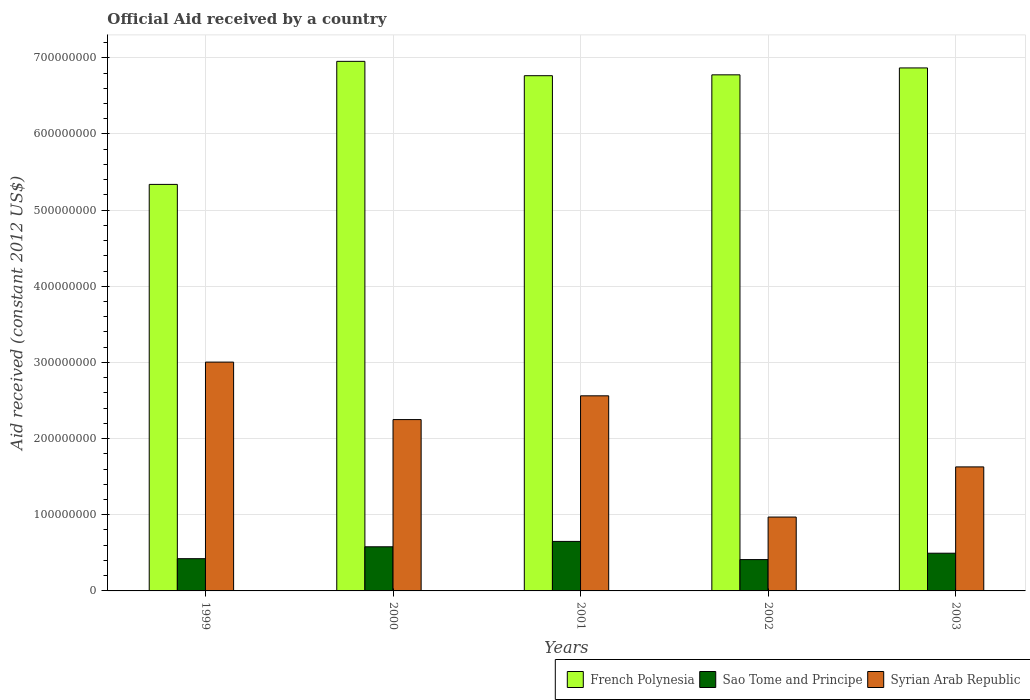Are the number of bars on each tick of the X-axis equal?
Your response must be concise. Yes. How many bars are there on the 2nd tick from the right?
Give a very brief answer. 3. What is the label of the 2nd group of bars from the left?
Your answer should be compact. 2000. In how many cases, is the number of bars for a given year not equal to the number of legend labels?
Your response must be concise. 0. What is the net official aid received in Syrian Arab Republic in 2000?
Your answer should be compact. 2.25e+08. Across all years, what is the maximum net official aid received in Sao Tome and Principe?
Keep it short and to the point. 6.50e+07. Across all years, what is the minimum net official aid received in Syrian Arab Republic?
Offer a very short reply. 9.70e+07. In which year was the net official aid received in French Polynesia minimum?
Make the answer very short. 1999. What is the total net official aid received in Sao Tome and Principe in the graph?
Offer a very short reply. 2.56e+08. What is the difference between the net official aid received in French Polynesia in 2001 and that in 2002?
Give a very brief answer. -1.13e+06. What is the difference between the net official aid received in French Polynesia in 2002 and the net official aid received in Sao Tome and Principe in 1999?
Your response must be concise. 6.35e+08. What is the average net official aid received in Sao Tome and Principe per year?
Provide a succinct answer. 5.12e+07. In the year 2001, what is the difference between the net official aid received in Sao Tome and Principe and net official aid received in French Polynesia?
Your answer should be very brief. -6.11e+08. In how many years, is the net official aid received in Sao Tome and Principe greater than 120000000 US$?
Offer a very short reply. 0. What is the ratio of the net official aid received in Sao Tome and Principe in 2002 to that in 2003?
Offer a terse response. 0.83. What is the difference between the highest and the second highest net official aid received in French Polynesia?
Provide a short and direct response. 8.64e+06. What is the difference between the highest and the lowest net official aid received in Sao Tome and Principe?
Offer a terse response. 2.39e+07. In how many years, is the net official aid received in French Polynesia greater than the average net official aid received in French Polynesia taken over all years?
Provide a succinct answer. 4. Is the sum of the net official aid received in Sao Tome and Principe in 2002 and 2003 greater than the maximum net official aid received in French Polynesia across all years?
Give a very brief answer. No. What does the 2nd bar from the left in 2001 represents?
Offer a terse response. Sao Tome and Principe. What does the 1st bar from the right in 2002 represents?
Ensure brevity in your answer.  Syrian Arab Republic. Is it the case that in every year, the sum of the net official aid received in French Polynesia and net official aid received in Syrian Arab Republic is greater than the net official aid received in Sao Tome and Principe?
Keep it short and to the point. Yes. Are all the bars in the graph horizontal?
Provide a succinct answer. No. How many years are there in the graph?
Your answer should be very brief. 5. What is the difference between two consecutive major ticks on the Y-axis?
Your response must be concise. 1.00e+08. Are the values on the major ticks of Y-axis written in scientific E-notation?
Your answer should be compact. No. Does the graph contain grids?
Offer a terse response. Yes. What is the title of the graph?
Your answer should be compact. Official Aid received by a country. What is the label or title of the X-axis?
Your answer should be very brief. Years. What is the label or title of the Y-axis?
Ensure brevity in your answer.  Aid received (constant 2012 US$). What is the Aid received (constant 2012 US$) of French Polynesia in 1999?
Your response must be concise. 5.34e+08. What is the Aid received (constant 2012 US$) in Sao Tome and Principe in 1999?
Offer a very short reply. 4.23e+07. What is the Aid received (constant 2012 US$) in Syrian Arab Republic in 1999?
Your answer should be very brief. 3.00e+08. What is the Aid received (constant 2012 US$) in French Polynesia in 2000?
Make the answer very short. 6.95e+08. What is the Aid received (constant 2012 US$) of Sao Tome and Principe in 2000?
Your response must be concise. 5.80e+07. What is the Aid received (constant 2012 US$) in Syrian Arab Republic in 2000?
Offer a very short reply. 2.25e+08. What is the Aid received (constant 2012 US$) of French Polynesia in 2001?
Ensure brevity in your answer.  6.76e+08. What is the Aid received (constant 2012 US$) in Sao Tome and Principe in 2001?
Ensure brevity in your answer.  6.50e+07. What is the Aid received (constant 2012 US$) of Syrian Arab Republic in 2001?
Your answer should be very brief. 2.56e+08. What is the Aid received (constant 2012 US$) in French Polynesia in 2002?
Give a very brief answer. 6.78e+08. What is the Aid received (constant 2012 US$) of Sao Tome and Principe in 2002?
Make the answer very short. 4.11e+07. What is the Aid received (constant 2012 US$) of Syrian Arab Republic in 2002?
Your answer should be very brief. 9.70e+07. What is the Aid received (constant 2012 US$) in French Polynesia in 2003?
Your answer should be very brief. 6.87e+08. What is the Aid received (constant 2012 US$) in Sao Tome and Principe in 2003?
Ensure brevity in your answer.  4.95e+07. What is the Aid received (constant 2012 US$) in Syrian Arab Republic in 2003?
Ensure brevity in your answer.  1.63e+08. Across all years, what is the maximum Aid received (constant 2012 US$) of French Polynesia?
Keep it short and to the point. 6.95e+08. Across all years, what is the maximum Aid received (constant 2012 US$) of Sao Tome and Principe?
Your response must be concise. 6.50e+07. Across all years, what is the maximum Aid received (constant 2012 US$) in Syrian Arab Republic?
Your answer should be very brief. 3.00e+08. Across all years, what is the minimum Aid received (constant 2012 US$) of French Polynesia?
Provide a short and direct response. 5.34e+08. Across all years, what is the minimum Aid received (constant 2012 US$) in Sao Tome and Principe?
Your response must be concise. 4.11e+07. Across all years, what is the minimum Aid received (constant 2012 US$) of Syrian Arab Republic?
Your answer should be very brief. 9.70e+07. What is the total Aid received (constant 2012 US$) in French Polynesia in the graph?
Make the answer very short. 3.27e+09. What is the total Aid received (constant 2012 US$) in Sao Tome and Principe in the graph?
Offer a very short reply. 2.56e+08. What is the total Aid received (constant 2012 US$) in Syrian Arab Republic in the graph?
Offer a terse response. 1.04e+09. What is the difference between the Aid received (constant 2012 US$) in French Polynesia in 1999 and that in 2000?
Ensure brevity in your answer.  -1.62e+08. What is the difference between the Aid received (constant 2012 US$) of Sao Tome and Principe in 1999 and that in 2000?
Give a very brief answer. -1.56e+07. What is the difference between the Aid received (constant 2012 US$) in Syrian Arab Republic in 1999 and that in 2000?
Provide a short and direct response. 7.55e+07. What is the difference between the Aid received (constant 2012 US$) in French Polynesia in 1999 and that in 2001?
Your answer should be compact. -1.43e+08. What is the difference between the Aid received (constant 2012 US$) of Sao Tome and Principe in 1999 and that in 2001?
Offer a very short reply. -2.27e+07. What is the difference between the Aid received (constant 2012 US$) in Syrian Arab Republic in 1999 and that in 2001?
Offer a terse response. 4.43e+07. What is the difference between the Aid received (constant 2012 US$) of French Polynesia in 1999 and that in 2002?
Keep it short and to the point. -1.44e+08. What is the difference between the Aid received (constant 2012 US$) of Sao Tome and Principe in 1999 and that in 2002?
Make the answer very short. 1.20e+06. What is the difference between the Aid received (constant 2012 US$) in Syrian Arab Republic in 1999 and that in 2002?
Your answer should be very brief. 2.03e+08. What is the difference between the Aid received (constant 2012 US$) of French Polynesia in 1999 and that in 2003?
Your response must be concise. -1.53e+08. What is the difference between the Aid received (constant 2012 US$) in Sao Tome and Principe in 1999 and that in 2003?
Offer a terse response. -7.18e+06. What is the difference between the Aid received (constant 2012 US$) in Syrian Arab Republic in 1999 and that in 2003?
Your answer should be very brief. 1.38e+08. What is the difference between the Aid received (constant 2012 US$) of French Polynesia in 2000 and that in 2001?
Offer a very short reply. 1.88e+07. What is the difference between the Aid received (constant 2012 US$) of Sao Tome and Principe in 2000 and that in 2001?
Make the answer very short. -7.05e+06. What is the difference between the Aid received (constant 2012 US$) in Syrian Arab Republic in 2000 and that in 2001?
Your answer should be very brief. -3.12e+07. What is the difference between the Aid received (constant 2012 US$) of French Polynesia in 2000 and that in 2002?
Make the answer very short. 1.77e+07. What is the difference between the Aid received (constant 2012 US$) in Sao Tome and Principe in 2000 and that in 2002?
Give a very brief answer. 1.68e+07. What is the difference between the Aid received (constant 2012 US$) of Syrian Arab Republic in 2000 and that in 2002?
Give a very brief answer. 1.28e+08. What is the difference between the Aid received (constant 2012 US$) of French Polynesia in 2000 and that in 2003?
Your answer should be very brief. 8.64e+06. What is the difference between the Aid received (constant 2012 US$) in Sao Tome and Principe in 2000 and that in 2003?
Keep it short and to the point. 8.43e+06. What is the difference between the Aid received (constant 2012 US$) in Syrian Arab Republic in 2000 and that in 2003?
Provide a succinct answer. 6.21e+07. What is the difference between the Aid received (constant 2012 US$) of French Polynesia in 2001 and that in 2002?
Provide a short and direct response. -1.13e+06. What is the difference between the Aid received (constant 2012 US$) of Sao Tome and Principe in 2001 and that in 2002?
Make the answer very short. 2.39e+07. What is the difference between the Aid received (constant 2012 US$) in Syrian Arab Republic in 2001 and that in 2002?
Your answer should be very brief. 1.59e+08. What is the difference between the Aid received (constant 2012 US$) in French Polynesia in 2001 and that in 2003?
Your response must be concise. -1.02e+07. What is the difference between the Aid received (constant 2012 US$) of Sao Tome and Principe in 2001 and that in 2003?
Ensure brevity in your answer.  1.55e+07. What is the difference between the Aid received (constant 2012 US$) in Syrian Arab Republic in 2001 and that in 2003?
Your response must be concise. 9.33e+07. What is the difference between the Aid received (constant 2012 US$) in French Polynesia in 2002 and that in 2003?
Your response must be concise. -9.07e+06. What is the difference between the Aid received (constant 2012 US$) of Sao Tome and Principe in 2002 and that in 2003?
Offer a very short reply. -8.38e+06. What is the difference between the Aid received (constant 2012 US$) of Syrian Arab Republic in 2002 and that in 2003?
Your response must be concise. -6.58e+07. What is the difference between the Aid received (constant 2012 US$) of French Polynesia in 1999 and the Aid received (constant 2012 US$) of Sao Tome and Principe in 2000?
Provide a succinct answer. 4.76e+08. What is the difference between the Aid received (constant 2012 US$) in French Polynesia in 1999 and the Aid received (constant 2012 US$) in Syrian Arab Republic in 2000?
Provide a short and direct response. 3.09e+08. What is the difference between the Aid received (constant 2012 US$) of Sao Tome and Principe in 1999 and the Aid received (constant 2012 US$) of Syrian Arab Republic in 2000?
Keep it short and to the point. -1.83e+08. What is the difference between the Aid received (constant 2012 US$) of French Polynesia in 1999 and the Aid received (constant 2012 US$) of Sao Tome and Principe in 2001?
Your answer should be compact. 4.69e+08. What is the difference between the Aid received (constant 2012 US$) of French Polynesia in 1999 and the Aid received (constant 2012 US$) of Syrian Arab Republic in 2001?
Your answer should be very brief. 2.78e+08. What is the difference between the Aid received (constant 2012 US$) in Sao Tome and Principe in 1999 and the Aid received (constant 2012 US$) in Syrian Arab Republic in 2001?
Your answer should be very brief. -2.14e+08. What is the difference between the Aid received (constant 2012 US$) in French Polynesia in 1999 and the Aid received (constant 2012 US$) in Sao Tome and Principe in 2002?
Give a very brief answer. 4.93e+08. What is the difference between the Aid received (constant 2012 US$) in French Polynesia in 1999 and the Aid received (constant 2012 US$) in Syrian Arab Republic in 2002?
Offer a terse response. 4.37e+08. What is the difference between the Aid received (constant 2012 US$) of Sao Tome and Principe in 1999 and the Aid received (constant 2012 US$) of Syrian Arab Republic in 2002?
Your answer should be compact. -5.46e+07. What is the difference between the Aid received (constant 2012 US$) of French Polynesia in 1999 and the Aid received (constant 2012 US$) of Sao Tome and Principe in 2003?
Provide a short and direct response. 4.84e+08. What is the difference between the Aid received (constant 2012 US$) of French Polynesia in 1999 and the Aid received (constant 2012 US$) of Syrian Arab Republic in 2003?
Offer a terse response. 3.71e+08. What is the difference between the Aid received (constant 2012 US$) of Sao Tome and Principe in 1999 and the Aid received (constant 2012 US$) of Syrian Arab Republic in 2003?
Your answer should be very brief. -1.20e+08. What is the difference between the Aid received (constant 2012 US$) in French Polynesia in 2000 and the Aid received (constant 2012 US$) in Sao Tome and Principe in 2001?
Give a very brief answer. 6.30e+08. What is the difference between the Aid received (constant 2012 US$) in French Polynesia in 2000 and the Aid received (constant 2012 US$) in Syrian Arab Republic in 2001?
Give a very brief answer. 4.39e+08. What is the difference between the Aid received (constant 2012 US$) of Sao Tome and Principe in 2000 and the Aid received (constant 2012 US$) of Syrian Arab Republic in 2001?
Your response must be concise. -1.98e+08. What is the difference between the Aid received (constant 2012 US$) in French Polynesia in 2000 and the Aid received (constant 2012 US$) in Sao Tome and Principe in 2002?
Your answer should be compact. 6.54e+08. What is the difference between the Aid received (constant 2012 US$) of French Polynesia in 2000 and the Aid received (constant 2012 US$) of Syrian Arab Republic in 2002?
Offer a very short reply. 5.98e+08. What is the difference between the Aid received (constant 2012 US$) in Sao Tome and Principe in 2000 and the Aid received (constant 2012 US$) in Syrian Arab Republic in 2002?
Your response must be concise. -3.90e+07. What is the difference between the Aid received (constant 2012 US$) of French Polynesia in 2000 and the Aid received (constant 2012 US$) of Sao Tome and Principe in 2003?
Keep it short and to the point. 6.46e+08. What is the difference between the Aid received (constant 2012 US$) in French Polynesia in 2000 and the Aid received (constant 2012 US$) in Syrian Arab Republic in 2003?
Provide a short and direct response. 5.32e+08. What is the difference between the Aid received (constant 2012 US$) of Sao Tome and Principe in 2000 and the Aid received (constant 2012 US$) of Syrian Arab Republic in 2003?
Offer a terse response. -1.05e+08. What is the difference between the Aid received (constant 2012 US$) in French Polynesia in 2001 and the Aid received (constant 2012 US$) in Sao Tome and Principe in 2002?
Provide a short and direct response. 6.35e+08. What is the difference between the Aid received (constant 2012 US$) in French Polynesia in 2001 and the Aid received (constant 2012 US$) in Syrian Arab Republic in 2002?
Provide a short and direct response. 5.79e+08. What is the difference between the Aid received (constant 2012 US$) of Sao Tome and Principe in 2001 and the Aid received (constant 2012 US$) of Syrian Arab Republic in 2002?
Offer a very short reply. -3.20e+07. What is the difference between the Aid received (constant 2012 US$) in French Polynesia in 2001 and the Aid received (constant 2012 US$) in Sao Tome and Principe in 2003?
Keep it short and to the point. 6.27e+08. What is the difference between the Aid received (constant 2012 US$) in French Polynesia in 2001 and the Aid received (constant 2012 US$) in Syrian Arab Republic in 2003?
Provide a succinct answer. 5.14e+08. What is the difference between the Aid received (constant 2012 US$) of Sao Tome and Principe in 2001 and the Aid received (constant 2012 US$) of Syrian Arab Republic in 2003?
Ensure brevity in your answer.  -9.78e+07. What is the difference between the Aid received (constant 2012 US$) in French Polynesia in 2002 and the Aid received (constant 2012 US$) in Sao Tome and Principe in 2003?
Provide a succinct answer. 6.28e+08. What is the difference between the Aid received (constant 2012 US$) of French Polynesia in 2002 and the Aid received (constant 2012 US$) of Syrian Arab Republic in 2003?
Ensure brevity in your answer.  5.15e+08. What is the difference between the Aid received (constant 2012 US$) in Sao Tome and Principe in 2002 and the Aid received (constant 2012 US$) in Syrian Arab Republic in 2003?
Your response must be concise. -1.22e+08. What is the average Aid received (constant 2012 US$) of French Polynesia per year?
Your answer should be very brief. 6.54e+08. What is the average Aid received (constant 2012 US$) of Sao Tome and Principe per year?
Keep it short and to the point. 5.12e+07. What is the average Aid received (constant 2012 US$) of Syrian Arab Republic per year?
Make the answer very short. 2.08e+08. In the year 1999, what is the difference between the Aid received (constant 2012 US$) of French Polynesia and Aid received (constant 2012 US$) of Sao Tome and Principe?
Your answer should be very brief. 4.91e+08. In the year 1999, what is the difference between the Aid received (constant 2012 US$) in French Polynesia and Aid received (constant 2012 US$) in Syrian Arab Republic?
Offer a terse response. 2.33e+08. In the year 1999, what is the difference between the Aid received (constant 2012 US$) in Sao Tome and Principe and Aid received (constant 2012 US$) in Syrian Arab Republic?
Provide a succinct answer. -2.58e+08. In the year 2000, what is the difference between the Aid received (constant 2012 US$) of French Polynesia and Aid received (constant 2012 US$) of Sao Tome and Principe?
Make the answer very short. 6.37e+08. In the year 2000, what is the difference between the Aid received (constant 2012 US$) of French Polynesia and Aid received (constant 2012 US$) of Syrian Arab Republic?
Make the answer very short. 4.70e+08. In the year 2000, what is the difference between the Aid received (constant 2012 US$) of Sao Tome and Principe and Aid received (constant 2012 US$) of Syrian Arab Republic?
Make the answer very short. -1.67e+08. In the year 2001, what is the difference between the Aid received (constant 2012 US$) of French Polynesia and Aid received (constant 2012 US$) of Sao Tome and Principe?
Give a very brief answer. 6.11e+08. In the year 2001, what is the difference between the Aid received (constant 2012 US$) in French Polynesia and Aid received (constant 2012 US$) in Syrian Arab Republic?
Provide a short and direct response. 4.20e+08. In the year 2001, what is the difference between the Aid received (constant 2012 US$) of Sao Tome and Principe and Aid received (constant 2012 US$) of Syrian Arab Republic?
Offer a very short reply. -1.91e+08. In the year 2002, what is the difference between the Aid received (constant 2012 US$) in French Polynesia and Aid received (constant 2012 US$) in Sao Tome and Principe?
Keep it short and to the point. 6.36e+08. In the year 2002, what is the difference between the Aid received (constant 2012 US$) in French Polynesia and Aid received (constant 2012 US$) in Syrian Arab Republic?
Offer a very short reply. 5.81e+08. In the year 2002, what is the difference between the Aid received (constant 2012 US$) in Sao Tome and Principe and Aid received (constant 2012 US$) in Syrian Arab Republic?
Keep it short and to the point. -5.58e+07. In the year 2003, what is the difference between the Aid received (constant 2012 US$) of French Polynesia and Aid received (constant 2012 US$) of Sao Tome and Principe?
Ensure brevity in your answer.  6.37e+08. In the year 2003, what is the difference between the Aid received (constant 2012 US$) in French Polynesia and Aid received (constant 2012 US$) in Syrian Arab Republic?
Your response must be concise. 5.24e+08. In the year 2003, what is the difference between the Aid received (constant 2012 US$) of Sao Tome and Principe and Aid received (constant 2012 US$) of Syrian Arab Republic?
Make the answer very short. -1.13e+08. What is the ratio of the Aid received (constant 2012 US$) of French Polynesia in 1999 to that in 2000?
Offer a terse response. 0.77. What is the ratio of the Aid received (constant 2012 US$) of Sao Tome and Principe in 1999 to that in 2000?
Your response must be concise. 0.73. What is the ratio of the Aid received (constant 2012 US$) in Syrian Arab Republic in 1999 to that in 2000?
Give a very brief answer. 1.34. What is the ratio of the Aid received (constant 2012 US$) of French Polynesia in 1999 to that in 2001?
Give a very brief answer. 0.79. What is the ratio of the Aid received (constant 2012 US$) of Sao Tome and Principe in 1999 to that in 2001?
Provide a short and direct response. 0.65. What is the ratio of the Aid received (constant 2012 US$) in Syrian Arab Republic in 1999 to that in 2001?
Your response must be concise. 1.17. What is the ratio of the Aid received (constant 2012 US$) of French Polynesia in 1999 to that in 2002?
Keep it short and to the point. 0.79. What is the ratio of the Aid received (constant 2012 US$) in Sao Tome and Principe in 1999 to that in 2002?
Your response must be concise. 1.03. What is the ratio of the Aid received (constant 2012 US$) of Syrian Arab Republic in 1999 to that in 2002?
Your answer should be very brief. 3.1. What is the ratio of the Aid received (constant 2012 US$) of French Polynesia in 1999 to that in 2003?
Keep it short and to the point. 0.78. What is the ratio of the Aid received (constant 2012 US$) in Sao Tome and Principe in 1999 to that in 2003?
Offer a terse response. 0.85. What is the ratio of the Aid received (constant 2012 US$) of Syrian Arab Republic in 1999 to that in 2003?
Give a very brief answer. 1.85. What is the ratio of the Aid received (constant 2012 US$) in French Polynesia in 2000 to that in 2001?
Provide a short and direct response. 1.03. What is the ratio of the Aid received (constant 2012 US$) in Sao Tome and Principe in 2000 to that in 2001?
Keep it short and to the point. 0.89. What is the ratio of the Aid received (constant 2012 US$) in Syrian Arab Republic in 2000 to that in 2001?
Provide a short and direct response. 0.88. What is the ratio of the Aid received (constant 2012 US$) in French Polynesia in 2000 to that in 2002?
Your answer should be compact. 1.03. What is the ratio of the Aid received (constant 2012 US$) of Sao Tome and Principe in 2000 to that in 2002?
Your response must be concise. 1.41. What is the ratio of the Aid received (constant 2012 US$) in Syrian Arab Republic in 2000 to that in 2002?
Offer a very short reply. 2.32. What is the ratio of the Aid received (constant 2012 US$) in French Polynesia in 2000 to that in 2003?
Your answer should be very brief. 1.01. What is the ratio of the Aid received (constant 2012 US$) in Sao Tome and Principe in 2000 to that in 2003?
Your response must be concise. 1.17. What is the ratio of the Aid received (constant 2012 US$) in Syrian Arab Republic in 2000 to that in 2003?
Provide a short and direct response. 1.38. What is the ratio of the Aid received (constant 2012 US$) in French Polynesia in 2001 to that in 2002?
Ensure brevity in your answer.  1. What is the ratio of the Aid received (constant 2012 US$) in Sao Tome and Principe in 2001 to that in 2002?
Make the answer very short. 1.58. What is the ratio of the Aid received (constant 2012 US$) of Syrian Arab Republic in 2001 to that in 2002?
Keep it short and to the point. 2.64. What is the ratio of the Aid received (constant 2012 US$) of French Polynesia in 2001 to that in 2003?
Your answer should be compact. 0.99. What is the ratio of the Aid received (constant 2012 US$) of Sao Tome and Principe in 2001 to that in 2003?
Provide a short and direct response. 1.31. What is the ratio of the Aid received (constant 2012 US$) of Syrian Arab Republic in 2001 to that in 2003?
Make the answer very short. 1.57. What is the ratio of the Aid received (constant 2012 US$) of French Polynesia in 2002 to that in 2003?
Provide a succinct answer. 0.99. What is the ratio of the Aid received (constant 2012 US$) of Sao Tome and Principe in 2002 to that in 2003?
Give a very brief answer. 0.83. What is the ratio of the Aid received (constant 2012 US$) in Syrian Arab Republic in 2002 to that in 2003?
Keep it short and to the point. 0.6. What is the difference between the highest and the second highest Aid received (constant 2012 US$) of French Polynesia?
Make the answer very short. 8.64e+06. What is the difference between the highest and the second highest Aid received (constant 2012 US$) in Sao Tome and Principe?
Provide a short and direct response. 7.05e+06. What is the difference between the highest and the second highest Aid received (constant 2012 US$) in Syrian Arab Republic?
Offer a very short reply. 4.43e+07. What is the difference between the highest and the lowest Aid received (constant 2012 US$) in French Polynesia?
Keep it short and to the point. 1.62e+08. What is the difference between the highest and the lowest Aid received (constant 2012 US$) of Sao Tome and Principe?
Your response must be concise. 2.39e+07. What is the difference between the highest and the lowest Aid received (constant 2012 US$) of Syrian Arab Republic?
Ensure brevity in your answer.  2.03e+08. 